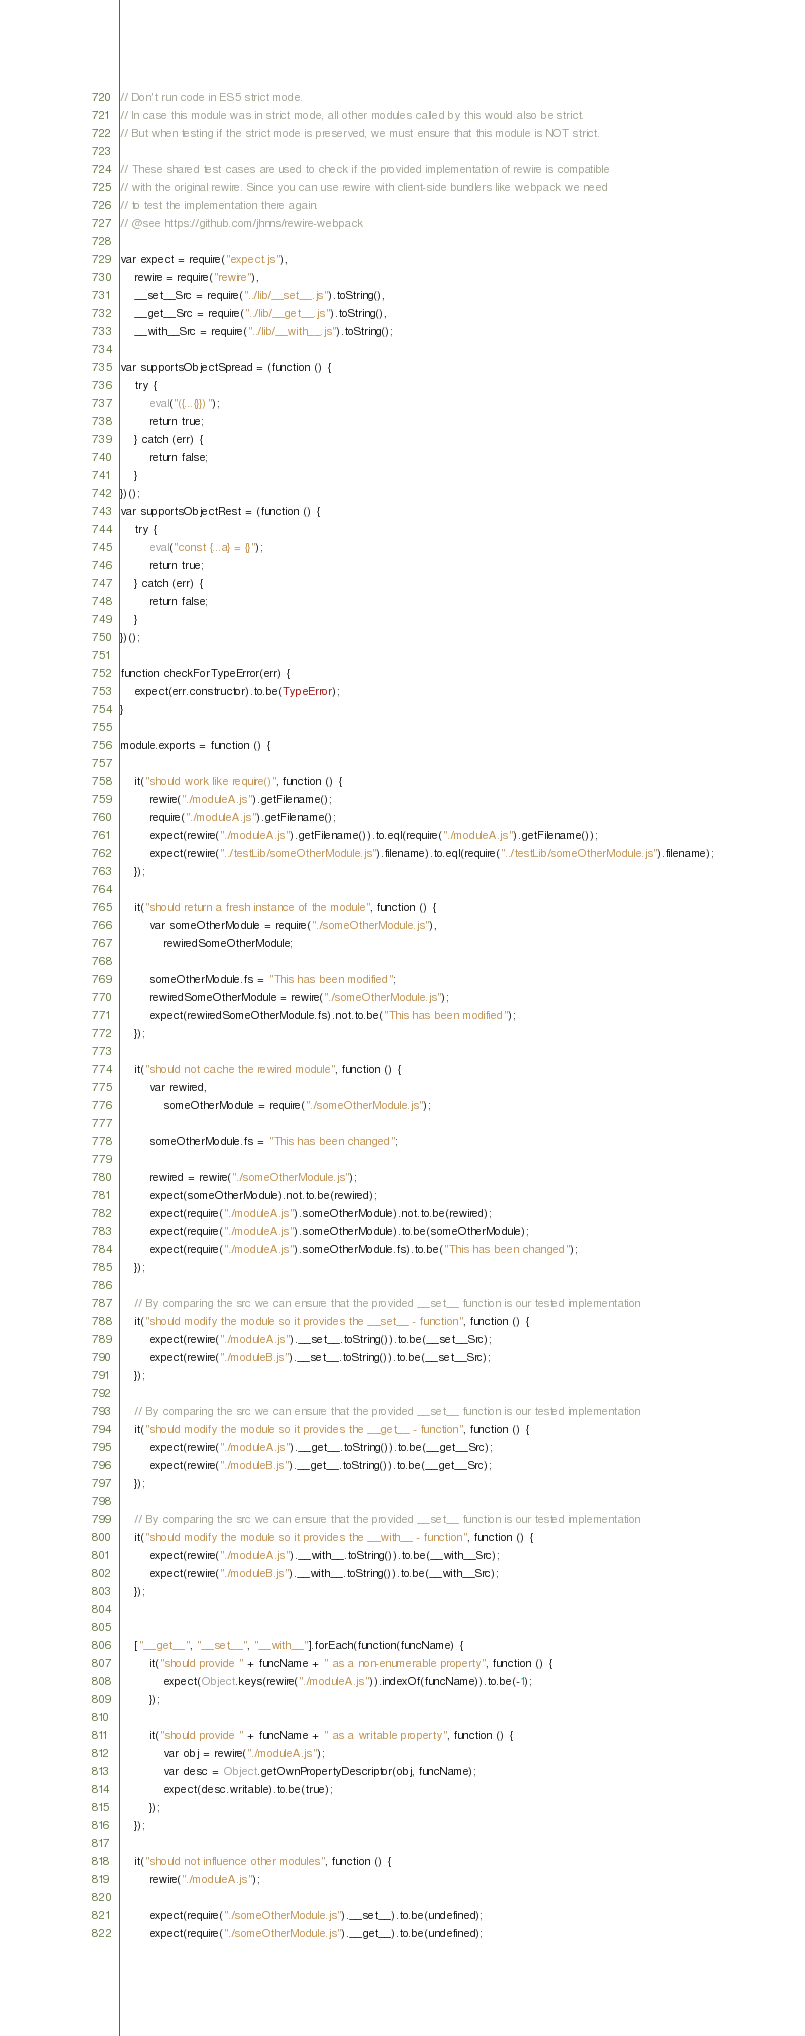<code> <loc_0><loc_0><loc_500><loc_500><_JavaScript_>// Don't run code in ES5 strict mode.
// In case this module was in strict mode, all other modules called by this would also be strict.
// But when testing if the strict mode is preserved, we must ensure that this module is NOT strict.

// These shared test cases are used to check if the provided implementation of rewire is compatible
// with the original rewire. Since you can use rewire with client-side bundlers like webpack we need
// to test the implementation there again.
// @see https://github.com/jhnns/rewire-webpack

var expect = require("expect.js"),
    rewire = require("rewire"),
    __set__Src = require("../lib/__set__.js").toString(),
    __get__Src = require("../lib/__get__.js").toString(),
    __with__Src = require("../lib/__with__.js").toString();

var supportsObjectSpread = (function () {
    try {
        eval("({...{}})");
        return true;
    } catch (err) {
        return false;
    }
})();
var supportsObjectRest = (function () {
    try {
        eval("const {...a} = {}");
        return true;
    } catch (err) {
        return false;
    }
})();

function checkForTypeError(err) {
    expect(err.constructor).to.be(TypeError);
}

module.exports = function () {

    it("should work like require()", function () {
        rewire("./moduleA.js").getFilename();
        require("./moduleA.js").getFilename();
        expect(rewire("./moduleA.js").getFilename()).to.eql(require("./moduleA.js").getFilename());
        expect(rewire("../testLib/someOtherModule.js").filename).to.eql(require("../testLib/someOtherModule.js").filename);
    });

    it("should return a fresh instance of the module", function () {
        var someOtherModule = require("./someOtherModule.js"),
            rewiredSomeOtherModule;

        someOtherModule.fs = "This has been modified";
        rewiredSomeOtherModule = rewire("./someOtherModule.js");
        expect(rewiredSomeOtherModule.fs).not.to.be("This has been modified");
    });

    it("should not cache the rewired module", function () {
        var rewired,
            someOtherModule = require("./someOtherModule.js");

        someOtherModule.fs = "This has been changed";

        rewired = rewire("./someOtherModule.js");
        expect(someOtherModule).not.to.be(rewired);
        expect(require("./moduleA.js").someOtherModule).not.to.be(rewired);
        expect(require("./moduleA.js").someOtherModule).to.be(someOtherModule);
        expect(require("./moduleA.js").someOtherModule.fs).to.be("This has been changed");
    });

    // By comparing the src we can ensure that the provided __set__ function is our tested implementation
    it("should modify the module so it provides the __set__ - function", function () {
        expect(rewire("./moduleA.js").__set__.toString()).to.be(__set__Src);
        expect(rewire("./moduleB.js").__set__.toString()).to.be(__set__Src);
    });

    // By comparing the src we can ensure that the provided __set__ function is our tested implementation
    it("should modify the module so it provides the __get__ - function", function () {
        expect(rewire("./moduleA.js").__get__.toString()).to.be(__get__Src);
        expect(rewire("./moduleB.js").__get__.toString()).to.be(__get__Src);
    });

    // By comparing the src we can ensure that the provided __set__ function is our tested implementation
    it("should modify the module so it provides the __with__ - function", function () {
        expect(rewire("./moduleA.js").__with__.toString()).to.be(__with__Src);
        expect(rewire("./moduleB.js").__with__.toString()).to.be(__with__Src);
    });


    ["__get__", "__set__", "__with__"].forEach(function(funcName) {
        it("should provide " + funcName + " as a non-enumerable property", function () {
            expect(Object.keys(rewire("./moduleA.js")).indexOf(funcName)).to.be(-1);
        });

        it("should provide " + funcName + " as a writable property", function () {
            var obj = rewire("./moduleA.js");
            var desc = Object.getOwnPropertyDescriptor(obj, funcName);
            expect(desc.writable).to.be(true);
        });
    });

    it("should not influence other modules", function () {
        rewire("./moduleA.js");

        expect(require("./someOtherModule.js").__set__).to.be(undefined);
        expect(require("./someOtherModule.js").__get__).to.be(undefined);</code> 